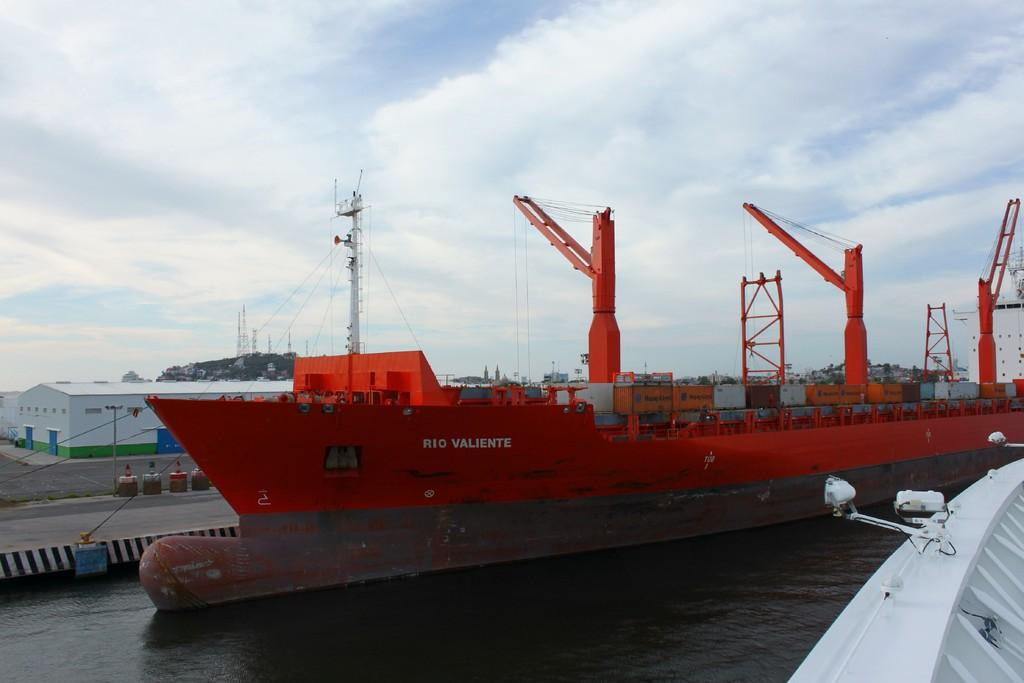Provide a one-sentence caption for the provided image. The Rio Valentine is a huge red ship parked at this bay. 